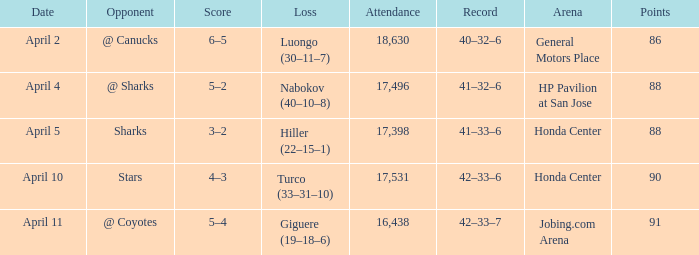Which Attendance has more than 90 points? 16438.0. 